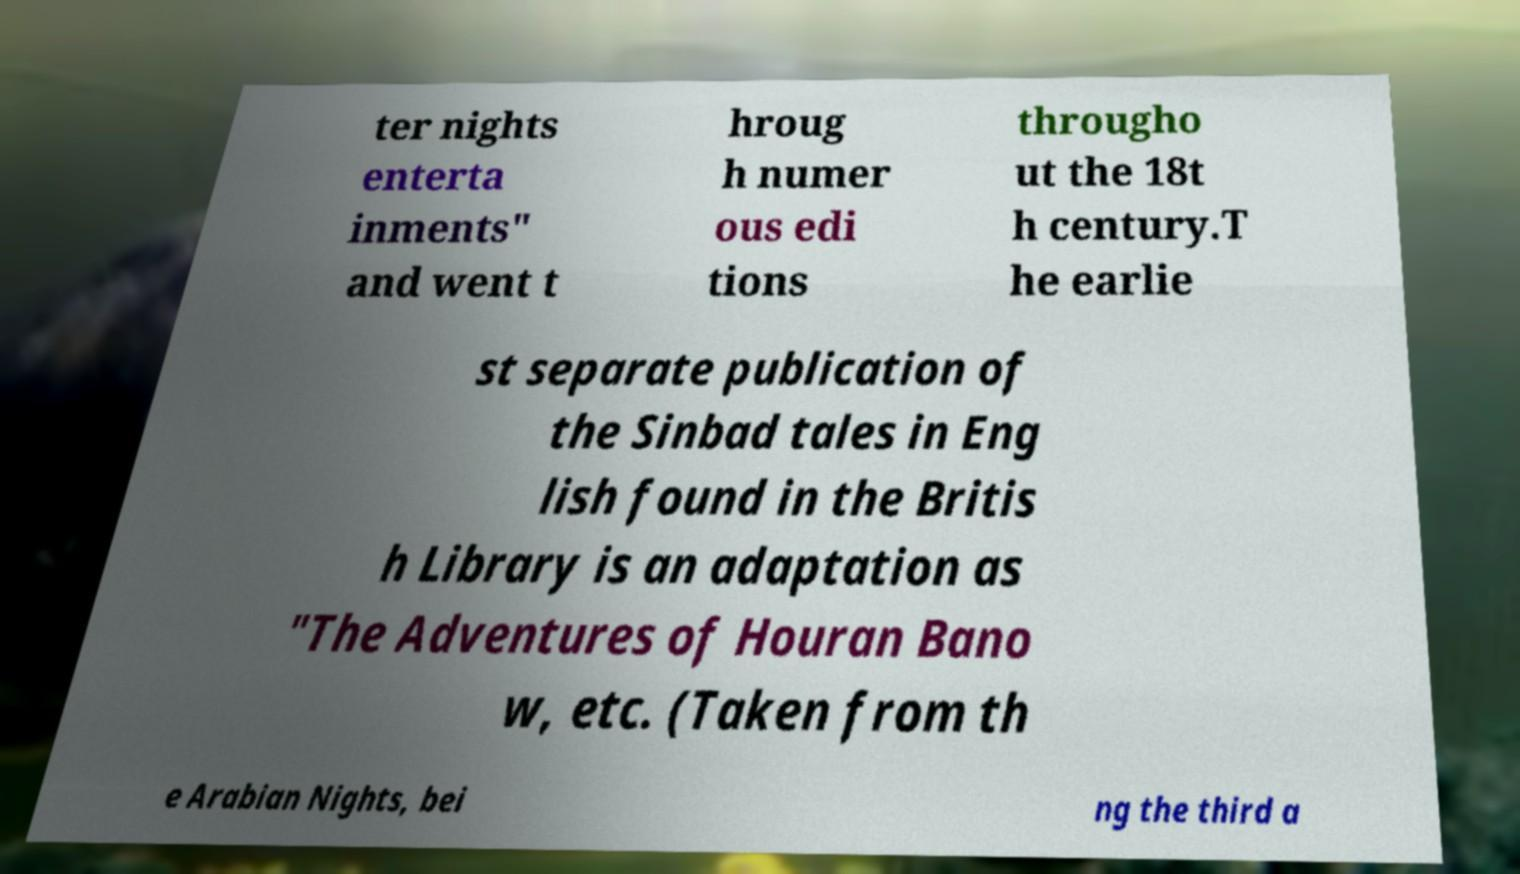Can you read and provide the text displayed in the image?This photo seems to have some interesting text. Can you extract and type it out for me? ter nights enterta inments" and went t hroug h numer ous edi tions througho ut the 18t h century.T he earlie st separate publication of the Sinbad tales in Eng lish found in the Britis h Library is an adaptation as "The Adventures of Houran Bano w, etc. (Taken from th e Arabian Nights, bei ng the third a 